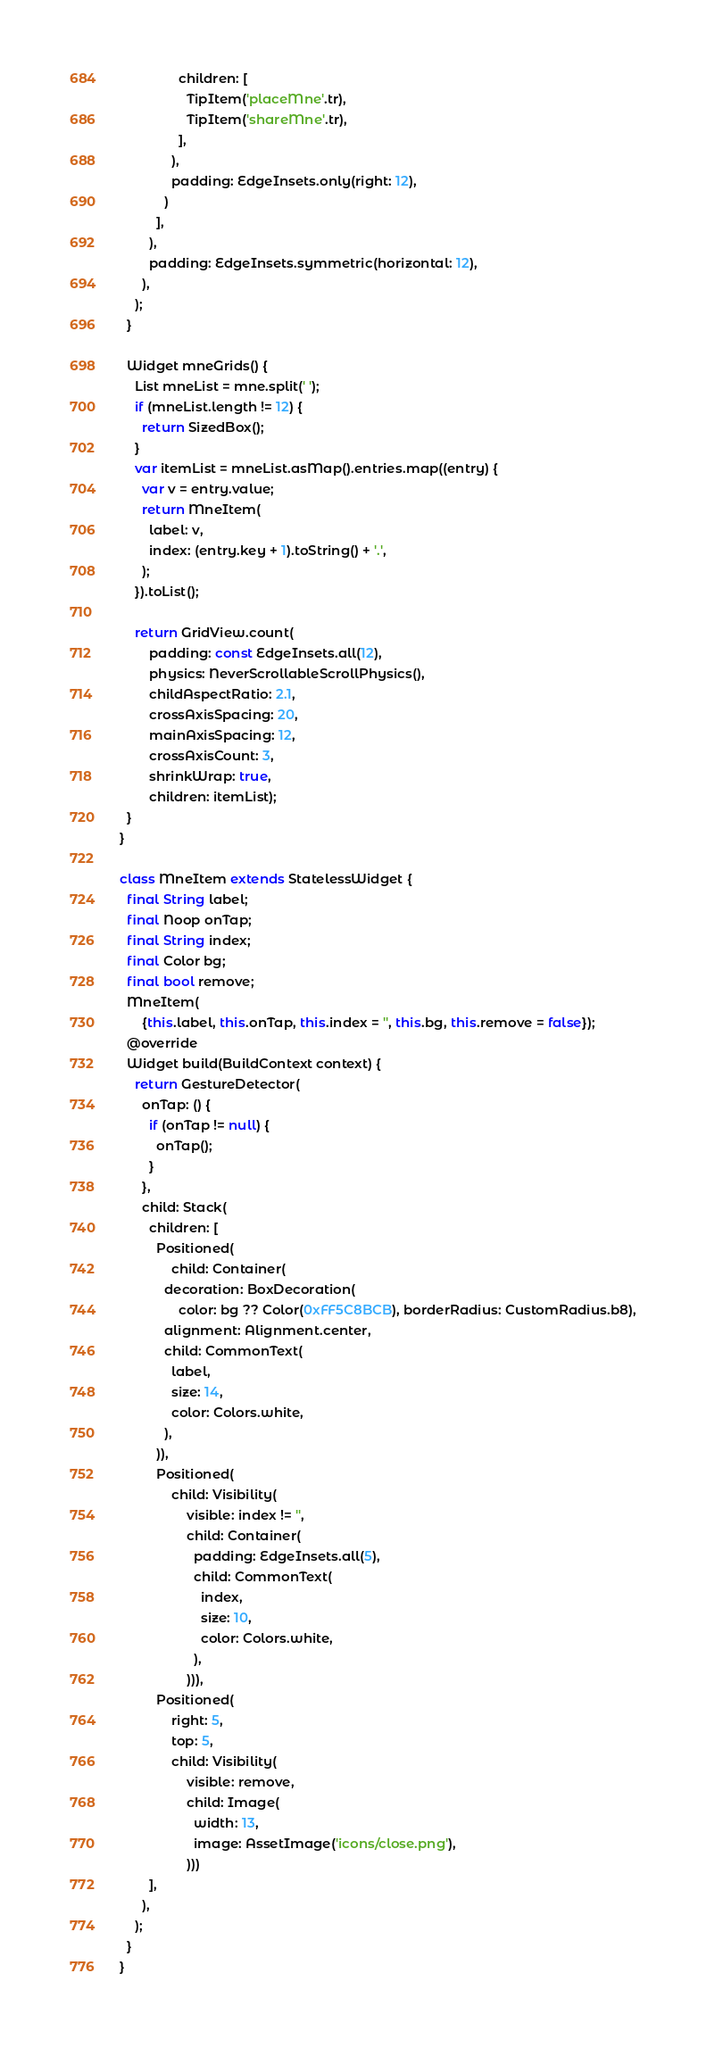<code> <loc_0><loc_0><loc_500><loc_500><_Dart_>                children: [
                  TipItem('placeMne'.tr),
                  TipItem('shareMne'.tr),
                ],
              ),
              padding: EdgeInsets.only(right: 12),
            )
          ],
        ),
        padding: EdgeInsets.symmetric(horizontal: 12),
      ),
    );
  }

  Widget mneGrids() {
    List mneList = mne.split(' ');
    if (mneList.length != 12) {
      return SizedBox();
    }
    var itemList = mneList.asMap().entries.map((entry) {
      var v = entry.value;
      return MneItem(
        label: v,
        index: (entry.key + 1).toString() + '.',
      );
    }).toList();

    return GridView.count(
        padding: const EdgeInsets.all(12),
        physics: NeverScrollableScrollPhysics(),
        childAspectRatio: 2.1,
        crossAxisSpacing: 20,
        mainAxisSpacing: 12,
        crossAxisCount: 3,
        shrinkWrap: true,
        children: itemList);
  }
}

class MneItem extends StatelessWidget {
  final String label;
  final Noop onTap;
  final String index;
  final Color bg;
  final bool remove;
  MneItem(
      {this.label, this.onTap, this.index = '', this.bg, this.remove = false});
  @override
  Widget build(BuildContext context) {
    return GestureDetector(
      onTap: () {
        if (onTap != null) {
          onTap();
        }
      },
      child: Stack(
        children: [
          Positioned(
              child: Container(
            decoration: BoxDecoration(
                color: bg ?? Color(0xFF5C8BCB), borderRadius: CustomRadius.b8),
            alignment: Alignment.center,
            child: CommonText(
              label,
              size: 14,
              color: Colors.white,
            ),
          )),
          Positioned(
              child: Visibility(
                  visible: index != '',
                  child: Container(
                    padding: EdgeInsets.all(5),
                    child: CommonText(
                      index,
                      size: 10,
                      color: Colors.white,
                    ),
                  ))),
          Positioned(
              right: 5,
              top: 5,
              child: Visibility(
                  visible: remove,
                  child: Image(
                    width: 13,
                    image: AssetImage('icons/close.png'),
                  )))
        ],
      ),
    );
  }
}
</code> 